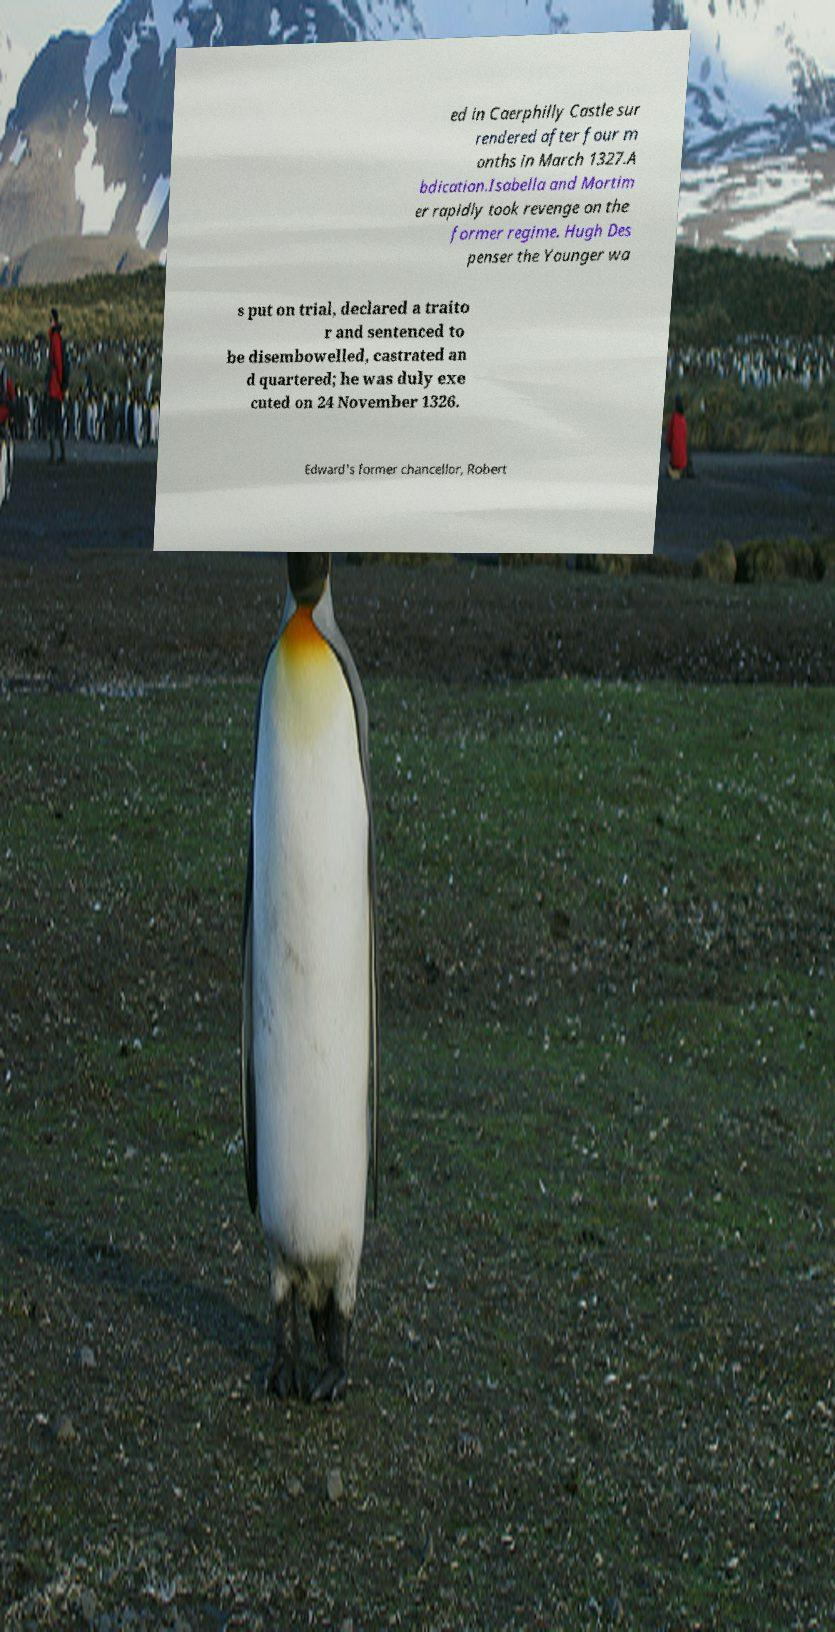For documentation purposes, I need the text within this image transcribed. Could you provide that? ed in Caerphilly Castle sur rendered after four m onths in March 1327.A bdication.Isabella and Mortim er rapidly took revenge on the former regime. Hugh Des penser the Younger wa s put on trial, declared a traito r and sentenced to be disembowelled, castrated an d quartered; he was duly exe cuted on 24 November 1326. Edward's former chancellor, Robert 